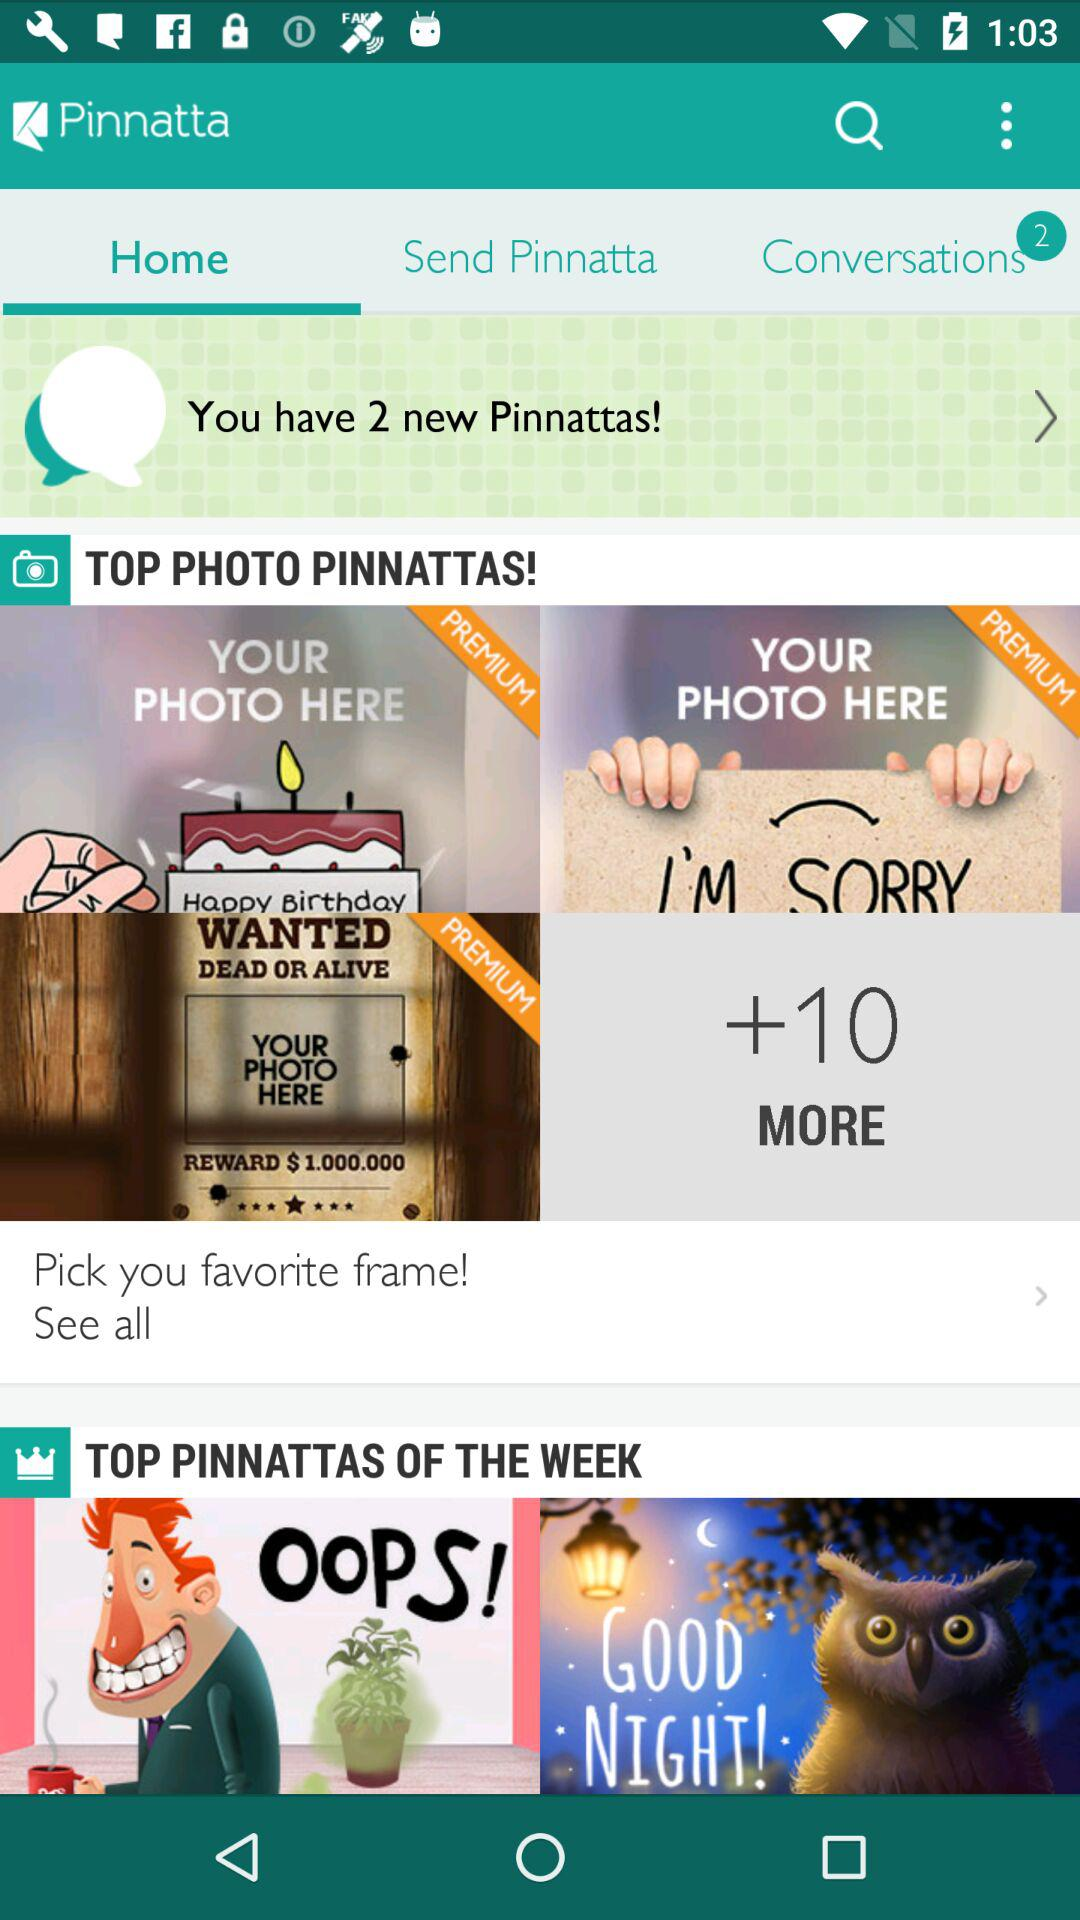How many more photos of "Pinnattas" are there? There are 10 more photos of "Pinnattas". 